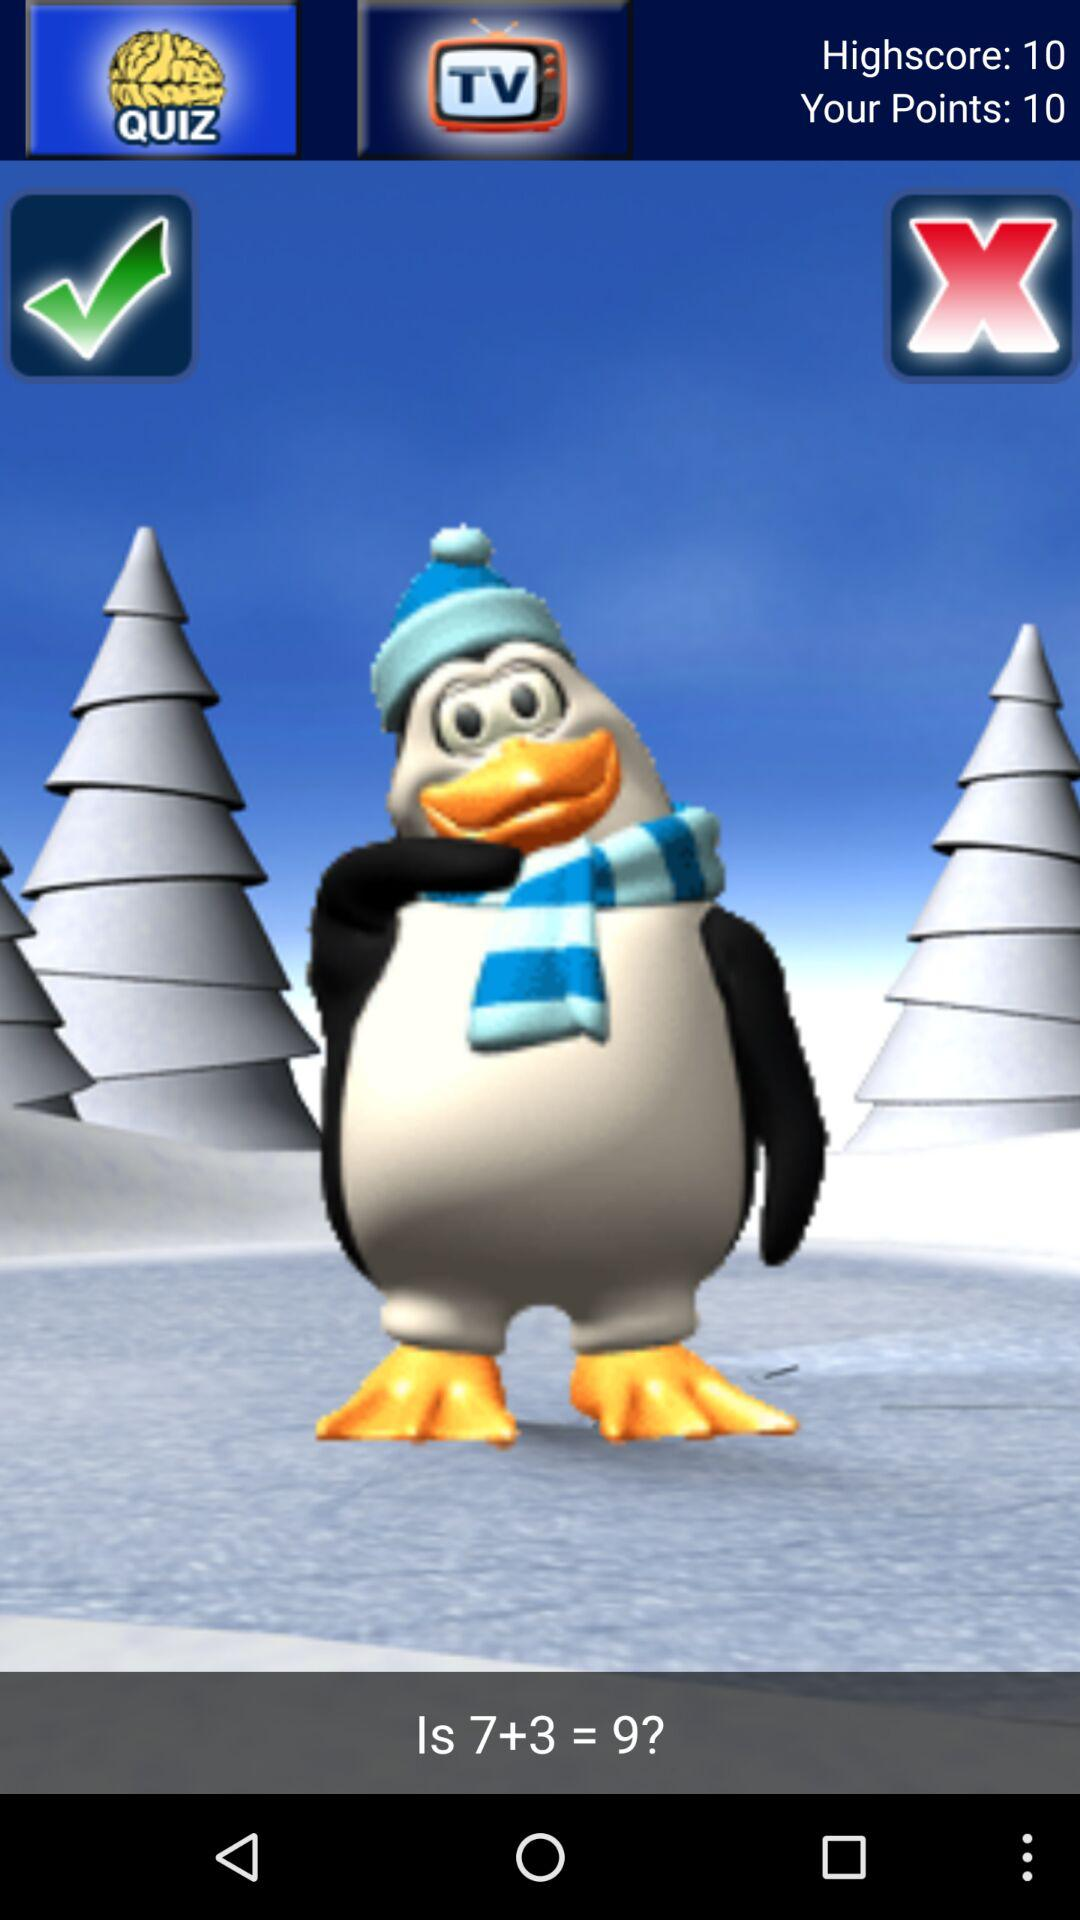How many points are there? There are 10 points. 